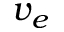Convert formula to latex. <formula><loc_0><loc_0><loc_500><loc_500>v _ { e }</formula> 